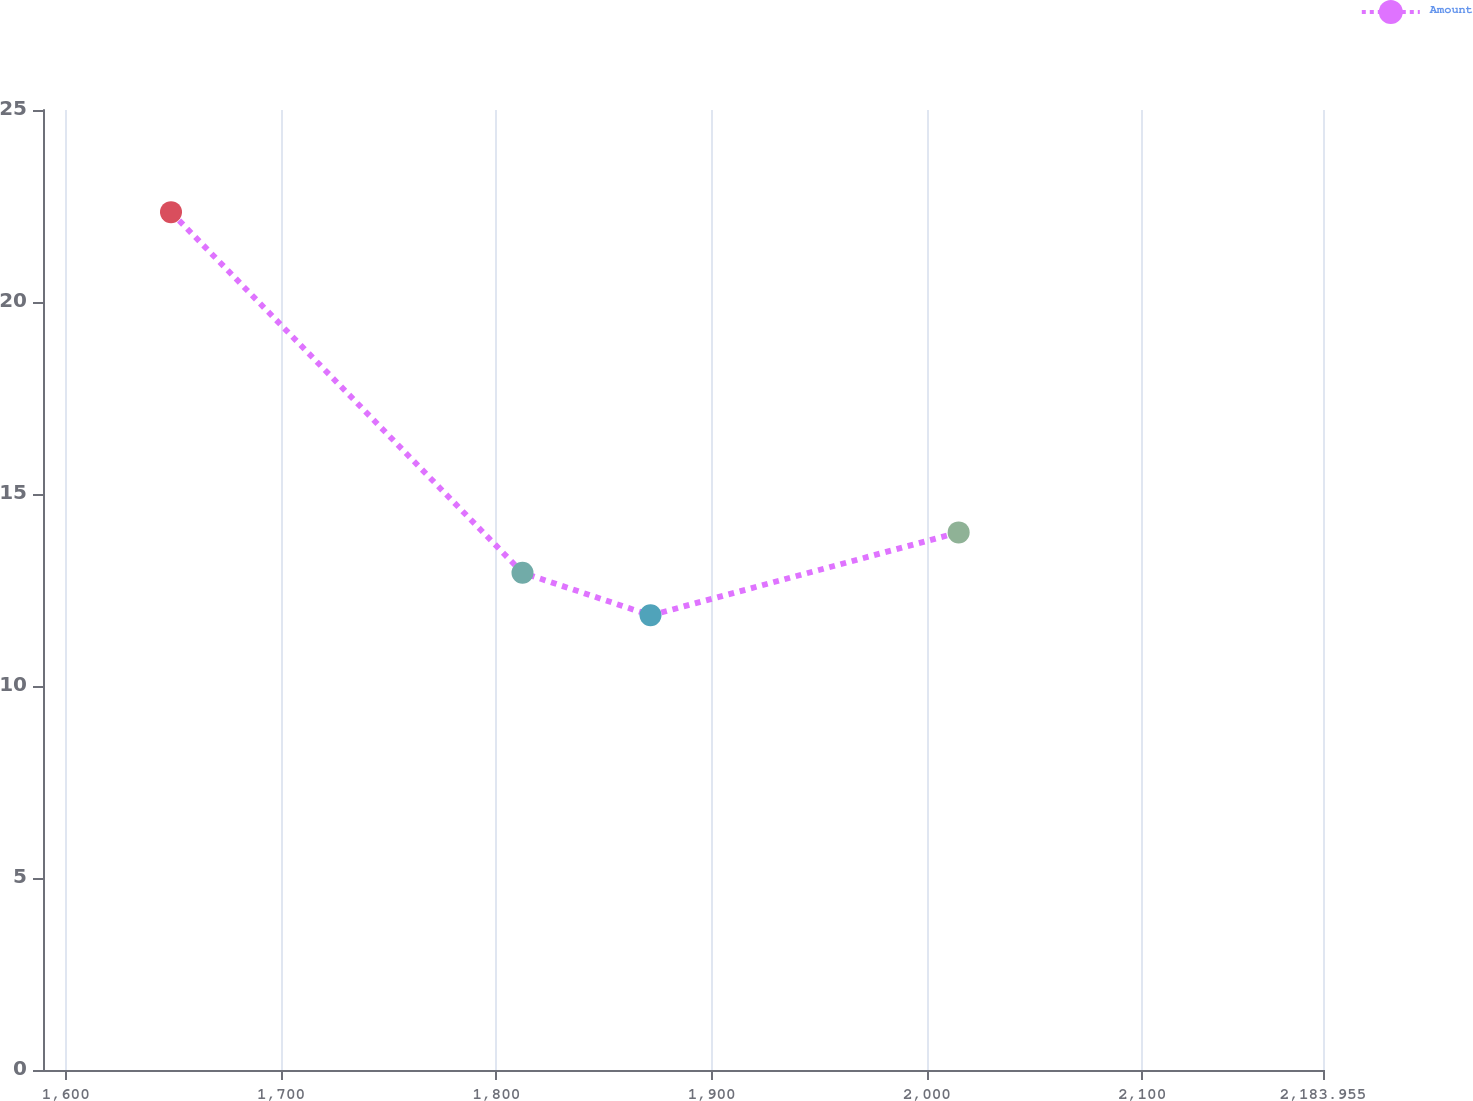Convert chart. <chart><loc_0><loc_0><loc_500><loc_500><line_chart><ecel><fcel>Amount<nl><fcel>1648.86<fcel>22.34<nl><fcel>1812.13<fcel>12.95<nl><fcel>1871.59<fcel>11.84<nl><fcel>2014.72<fcel>14<nl><fcel>2243.41<fcel>16.76<nl></chart> 